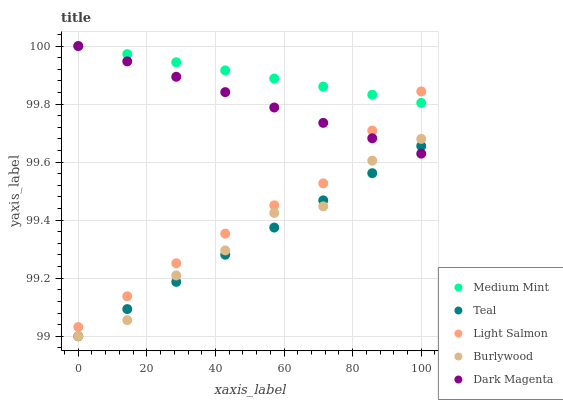Does Teal have the minimum area under the curve?
Answer yes or no. Yes. Does Medium Mint have the maximum area under the curve?
Answer yes or no. Yes. Does Burlywood have the minimum area under the curve?
Answer yes or no. No. Does Burlywood have the maximum area under the curve?
Answer yes or no. No. Is Dark Magenta the smoothest?
Answer yes or no. Yes. Is Burlywood the roughest?
Answer yes or no. Yes. Is Light Salmon the smoothest?
Answer yes or no. No. Is Light Salmon the roughest?
Answer yes or no. No. Does Burlywood have the lowest value?
Answer yes or no. Yes. Does Light Salmon have the lowest value?
Answer yes or no. No. Does Dark Magenta have the highest value?
Answer yes or no. Yes. Does Burlywood have the highest value?
Answer yes or no. No. Is Burlywood less than Medium Mint?
Answer yes or no. Yes. Is Light Salmon greater than Burlywood?
Answer yes or no. Yes. Does Light Salmon intersect Dark Magenta?
Answer yes or no. Yes. Is Light Salmon less than Dark Magenta?
Answer yes or no. No. Is Light Salmon greater than Dark Magenta?
Answer yes or no. No. Does Burlywood intersect Medium Mint?
Answer yes or no. No. 